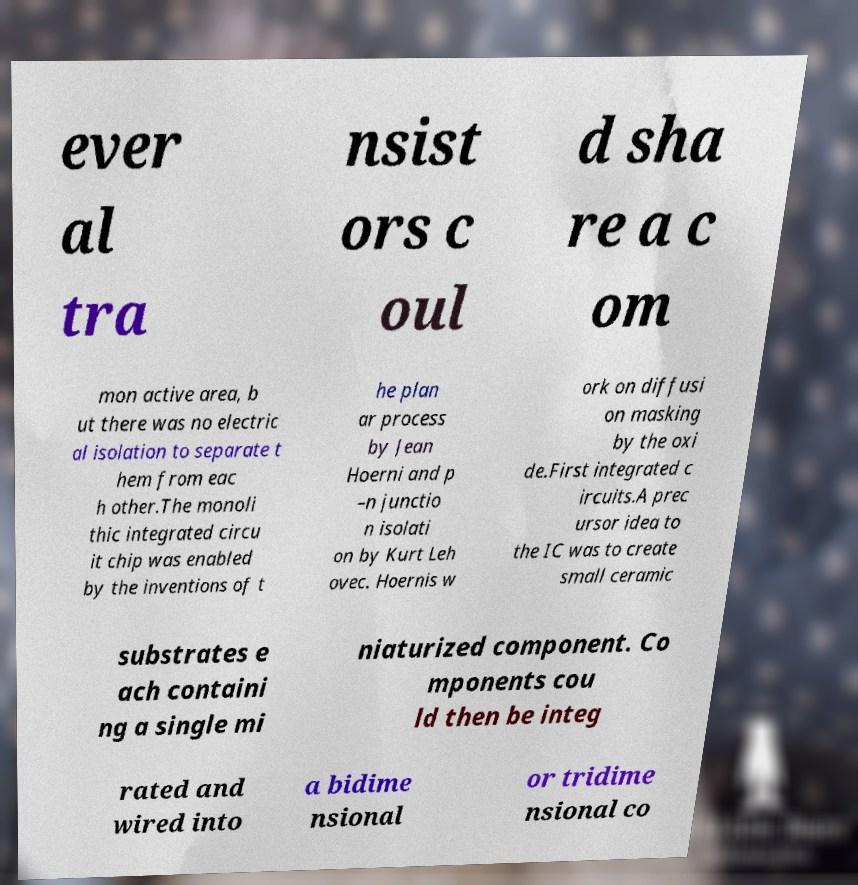Can you accurately transcribe the text from the provided image for me? ever al tra nsist ors c oul d sha re a c om mon active area, b ut there was no electric al isolation to separate t hem from eac h other.The monoli thic integrated circu it chip was enabled by the inventions of t he plan ar process by Jean Hoerni and p –n junctio n isolati on by Kurt Leh ovec. Hoernis w ork on diffusi on masking by the oxi de.First integrated c ircuits.A prec ursor idea to the IC was to create small ceramic substrates e ach containi ng a single mi niaturized component. Co mponents cou ld then be integ rated and wired into a bidime nsional or tridime nsional co 